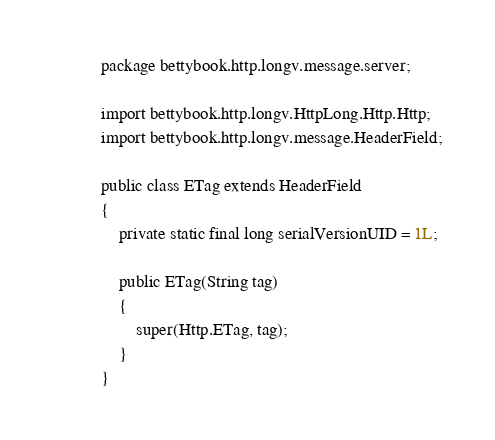<code> <loc_0><loc_0><loc_500><loc_500><_Java_>package bettybook.http.longv.message.server;

import bettybook.http.longv.HttpLong.Http.Http;
import bettybook.http.longv.message.HeaderField;

public class ETag extends HeaderField
{
	private static final long serialVersionUID = 1L;

	public ETag(String tag)
	{
		super(Http.ETag, tag);
	}
}
</code> 